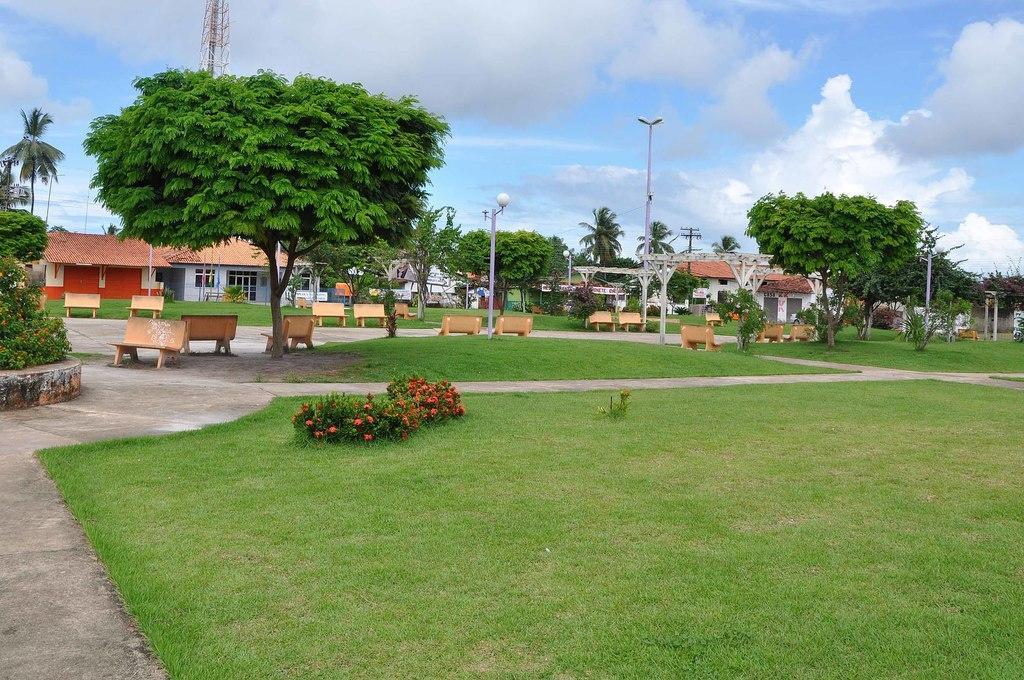Please provide a concise description of this image. In this image we can see a grassy land and a road. There is a blue and cloudy sky in the image. There is tower and many houses in the image. There are many trees and plants in the image. There are many flowers to the plant in the image. 